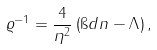<formula> <loc_0><loc_0><loc_500><loc_500>\varrho ^ { - 1 } = \frac { 4 } { \eta ^ { 2 } } \left ( \i d n - \Lambda \right ) ,</formula> 